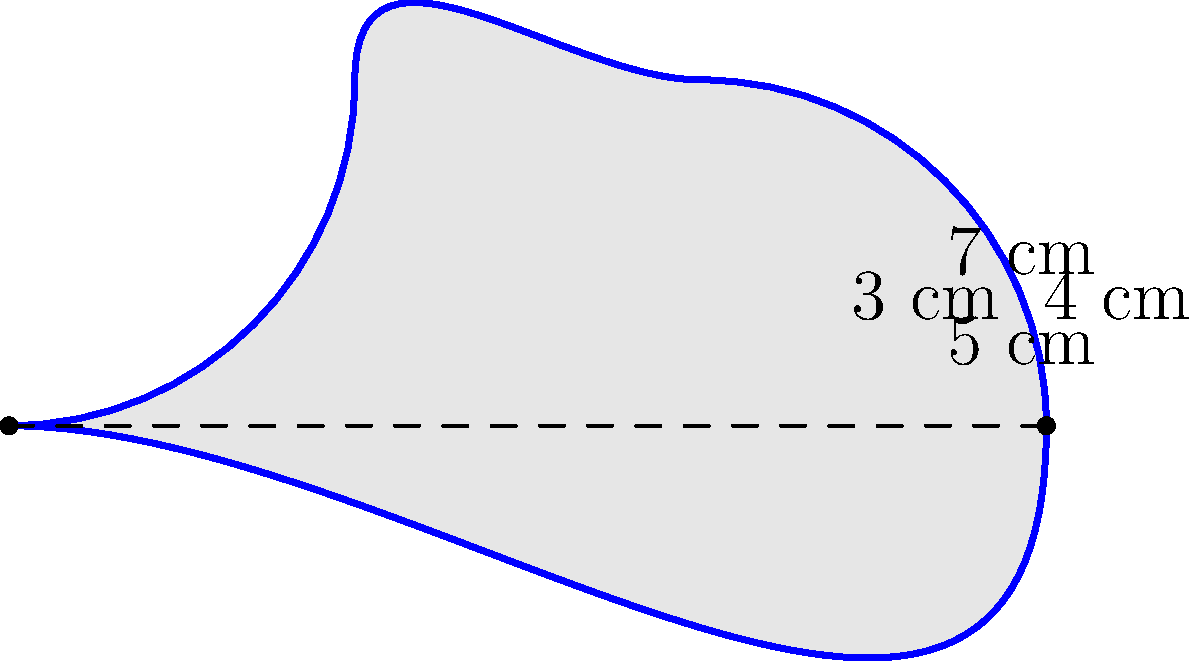A high-security lock has a complex shape with curved edges as shown in the diagram. The straight-line distance between the leftmost and rightmost points is 3 cm, while the top and bottom curved edges measure 7 cm and 5 cm respectively. The left and right curved edges measure 3 cm and 4 cm respectively. Calculate the perimeter of this lock shape. To calculate the perimeter of this complex lock shape, we need to sum up the lengths of all its edges. Let's break it down step by step:

1. Top curved edge: 7 cm
2. Bottom curved edge: 5 cm
3. Left curved edge: 3 cm
4. Right curved edge: 4 cm

The perimeter is the sum of all these edges:

$$\text{Perimeter} = 7 \text{ cm} + 5 \text{ cm} + 3 \text{ cm} + 4 \text{ cm}$$

$$\text{Perimeter} = 19 \text{ cm}$$

Note that we don't use the straight-line distance of 3 cm between the leftmost and rightmost points, as it's not part of the actual edge of the lock shape.
Answer: 19 cm 